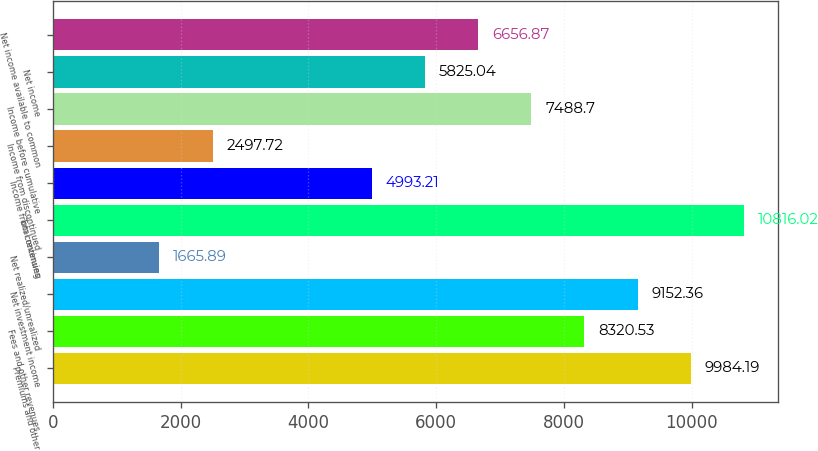Convert chart. <chart><loc_0><loc_0><loc_500><loc_500><bar_chart><fcel>Premiums and other<fcel>Fees and other revenues<fcel>Net investment income<fcel>Net realized/unrealized<fcel>Total revenues<fcel>Income from continuing<fcel>Income from discontinued<fcel>Income before cumulative<fcel>Net income<fcel>Net income available to common<nl><fcel>9984.19<fcel>8320.53<fcel>9152.36<fcel>1665.89<fcel>10816<fcel>4993.21<fcel>2497.72<fcel>7488.7<fcel>5825.04<fcel>6656.87<nl></chart> 